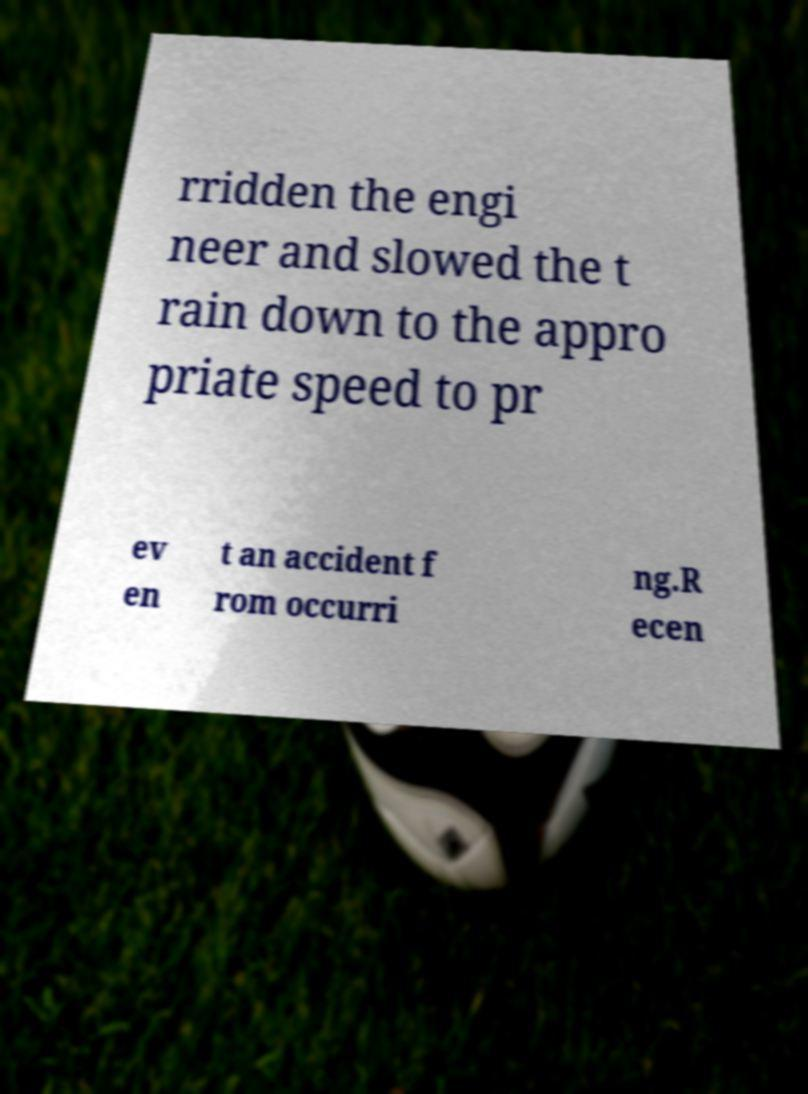I need the written content from this picture converted into text. Can you do that? rridden the engi neer and slowed the t rain down to the appro priate speed to pr ev en t an accident f rom occurri ng.R ecen 